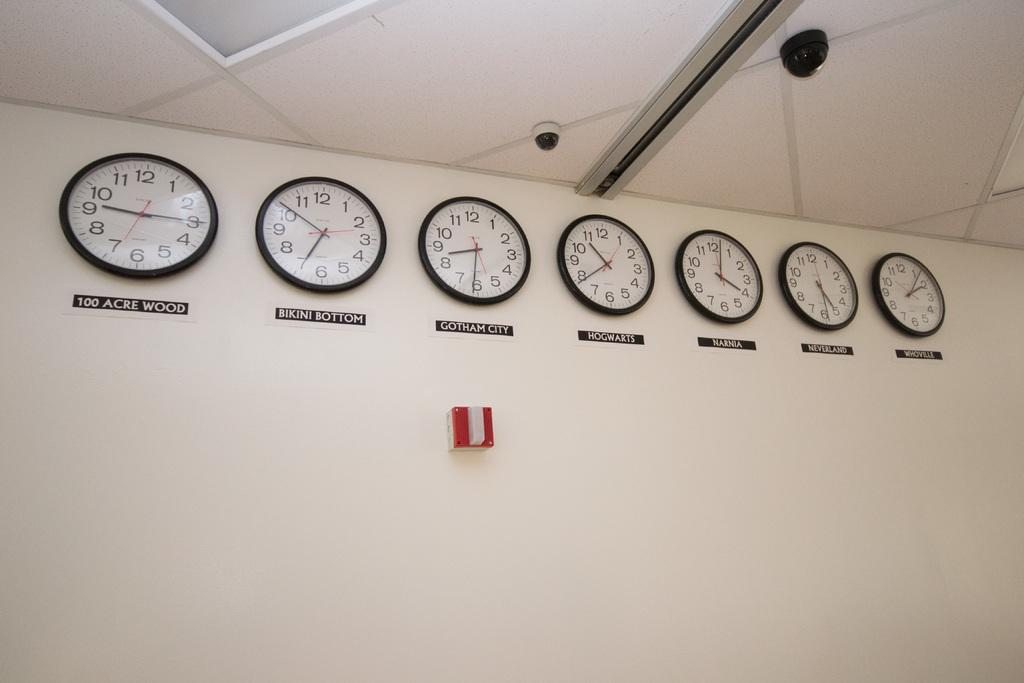<image>
Render a clear and concise summary of the photo. Seven clocks are lined up on wall and one shows the time for Bikini Bottom. 